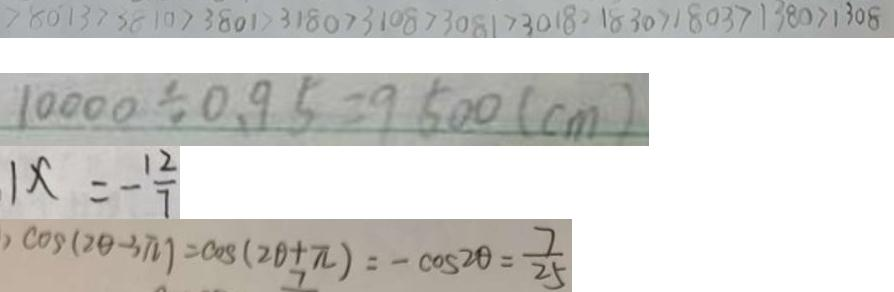<formula> <loc_0><loc_0><loc_500><loc_500>> 8 0 1 3 > 3 8 1 0 > 3 8 0 1 > 3 1 8 0 > 3 1 0 8 > 3 0 8 1 > 3 0 1 8 > 1 8 3 0 > 1 8 0 3 > 1 3 8 0 > 1 3 0 8 
 1 0 0 0 \div 0 . 9 5 = 9 5 0 0 ( c m ) 
 1 x = - \frac { 1 2 } { 7 } 
 \cos ( 2 \theta - 3 \pi ) = \cos ( 2 \theta + \pi ) = - \cos 2 \theta = \frac { 7 } { 2 5 }</formula> 